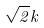<formula> <loc_0><loc_0><loc_500><loc_500>\sqrt { 2 } k</formula> 